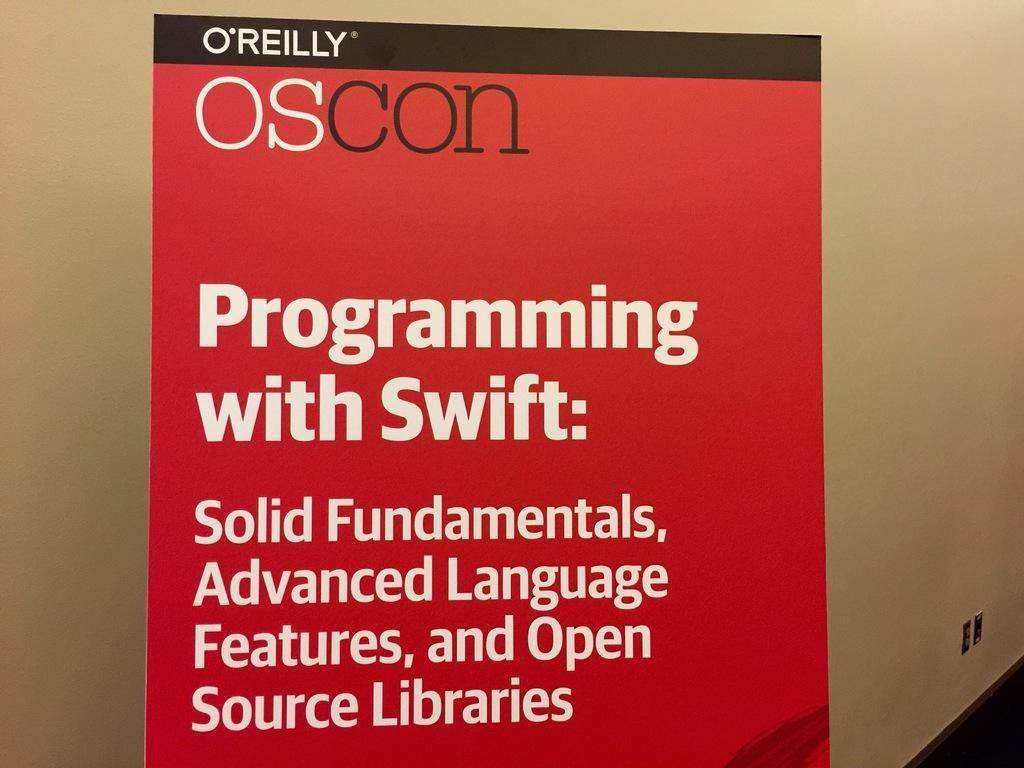<image>
Offer a succinct explanation of the picture presented. A red poster the says Programming with Swift: Solid Fundamentals, Advancedd Language Features, and Open Source Libraries. 